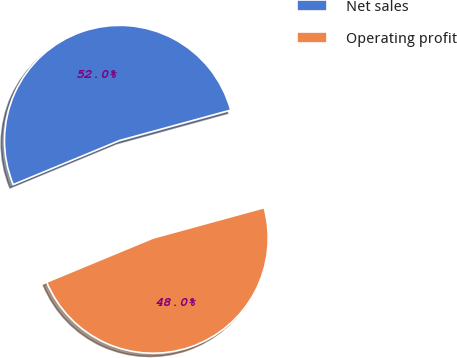Convert chart. <chart><loc_0><loc_0><loc_500><loc_500><pie_chart><fcel>Net sales<fcel>Operating profit<nl><fcel>52.0%<fcel>48.0%<nl></chart> 